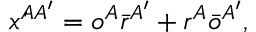Convert formula to latex. <formula><loc_0><loc_0><loc_500><loc_500>\acute { x } ^ { A A ^ { \prime } } = o ^ { A } \bar { r } ^ { A ^ { \prime } } + r ^ { A } \bar { o } ^ { A ^ { \prime } } ,</formula> 